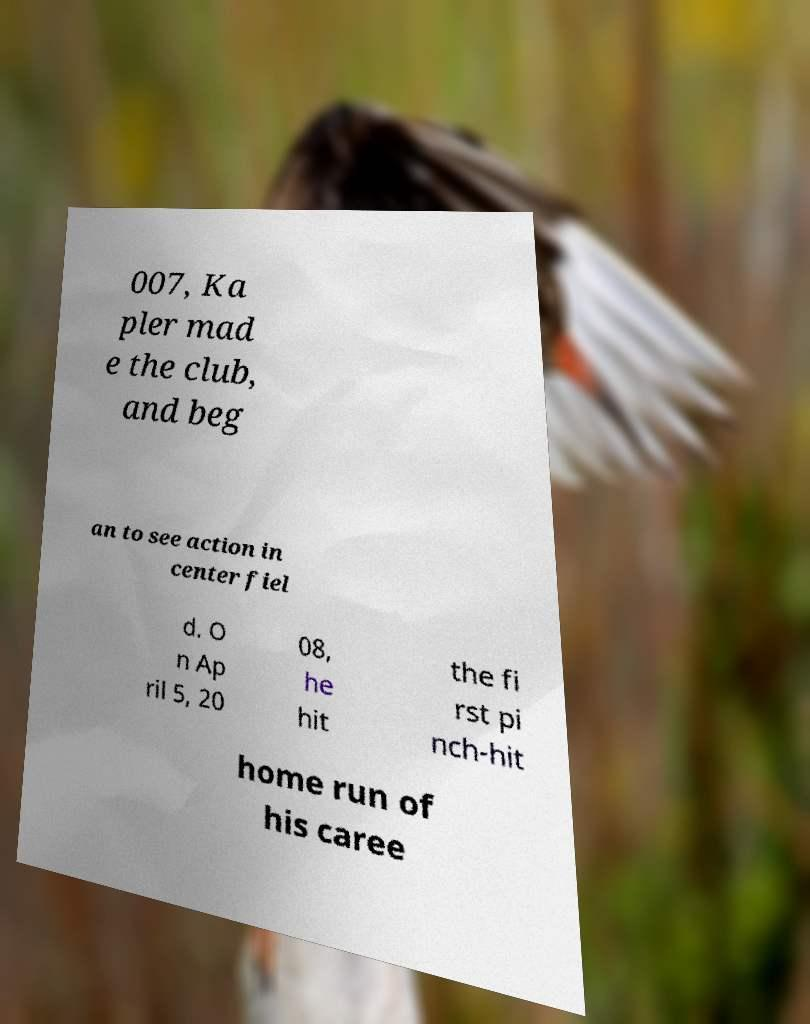Could you assist in decoding the text presented in this image and type it out clearly? 007, Ka pler mad e the club, and beg an to see action in center fiel d. O n Ap ril 5, 20 08, he hit the fi rst pi nch-hit home run of his caree 